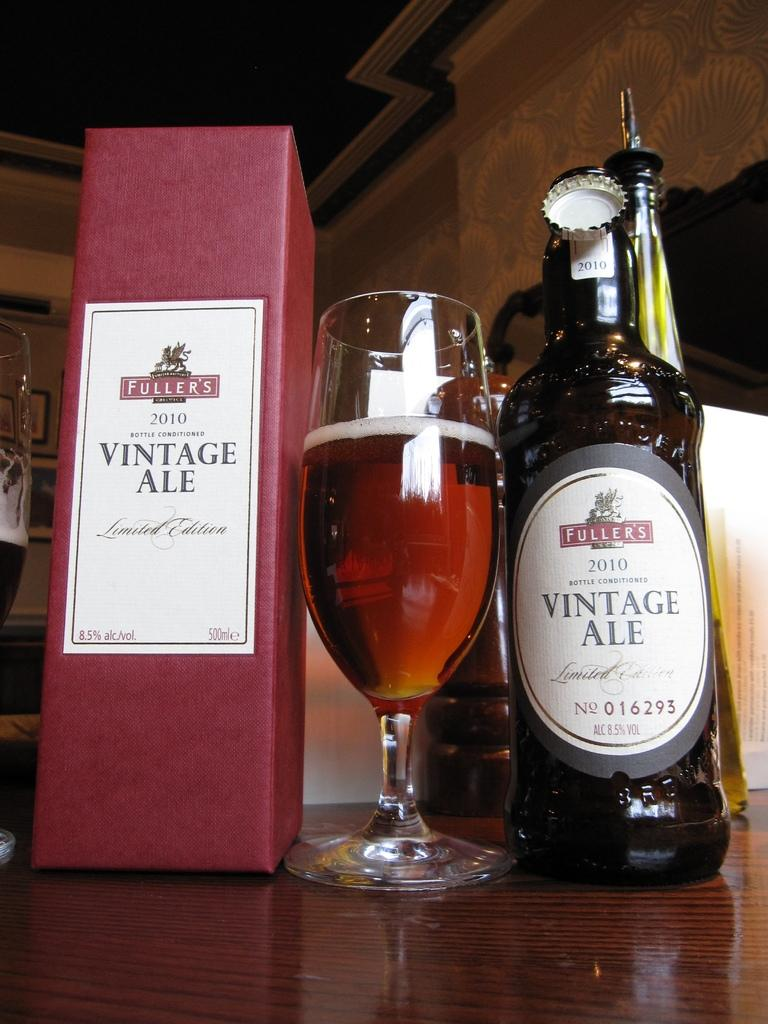Provide a one-sentence caption for the provided image. bottle of wine from vintage ale and glass ready to be served. 